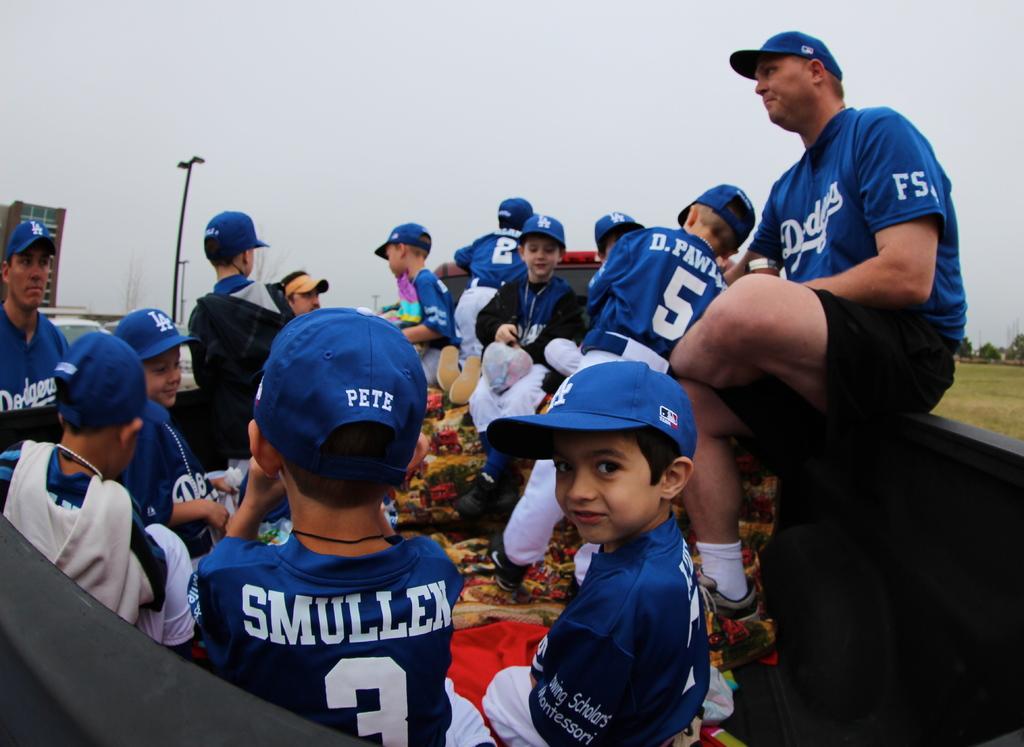What is number 3's first name?
Make the answer very short. Pete. What team is on the front of these jerseys?
Provide a succinct answer. Dodgers. 